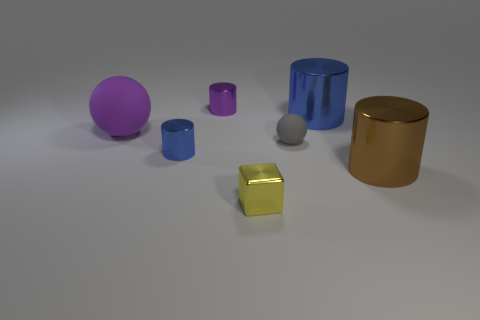How many other objects are there of the same shape as the tiny blue metallic thing?
Provide a succinct answer. 3. What number of blue objects are large cylinders or tiny matte objects?
Make the answer very short. 1. There is a big thing that is made of the same material as the small gray sphere; what is its color?
Your response must be concise. Purple. Is the big object that is in front of the large rubber thing made of the same material as the big thing left of the yellow metallic object?
Provide a short and direct response. No. The metal cylinder that is the same color as the large sphere is what size?
Provide a succinct answer. Small. What material is the blue cylinder that is on the left side of the block?
Give a very brief answer. Metal. There is a rubber object to the right of the big purple ball; does it have the same shape as the large metal object that is behind the large brown shiny cylinder?
Give a very brief answer. No. There is a cylinder that is the same color as the big matte sphere; what is it made of?
Your response must be concise. Metal. Is there a big yellow metal cylinder?
Make the answer very short. No. There is another big thing that is the same shape as the big brown object; what material is it?
Offer a terse response. Metal. 